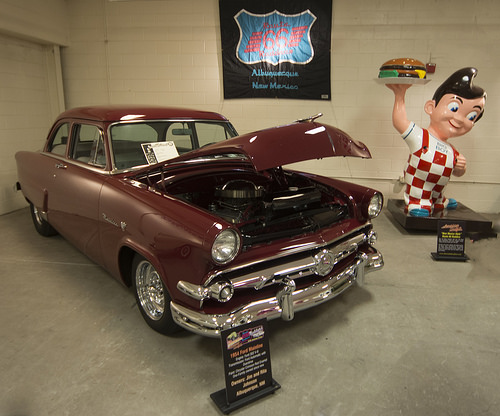<image>
Can you confirm if the statue is behind the car? No. The statue is not behind the car. From this viewpoint, the statue appears to be positioned elsewhere in the scene. 